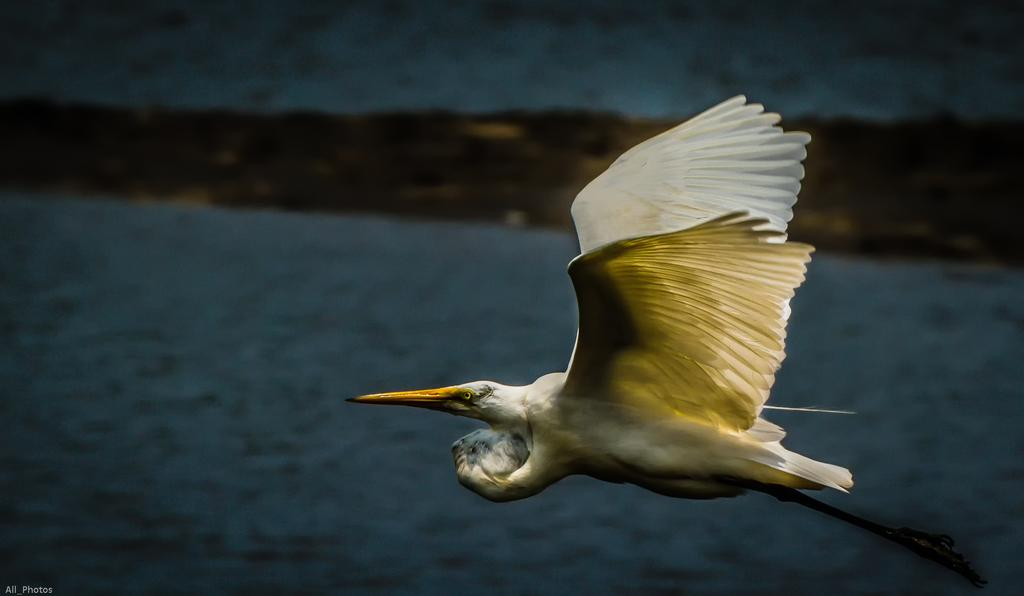What type of animal can be seen in the image? There is a bird in the image. What colors are present on the bird? The bird is cream, black, white, and grey in color. What is the bird doing in the image? The bird is flying in the air. What can be seen in the background of the image? There is ground and water visible in the background of the image. How many fingers does the bird have in the image? Birds do not have fingers; they have claws. However, the image does not show the bird's claws or any fingers. 